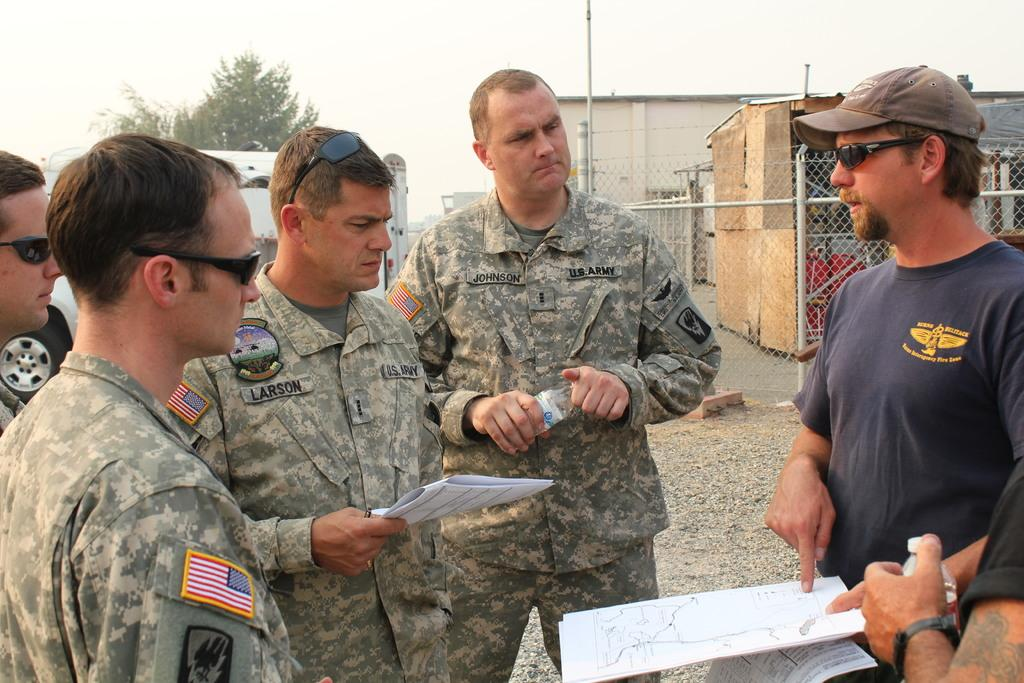What are the men in the image doing? The men in the image are standing on the ground. What are some of the men holding in their hands? Some of the men are holding papers in their hands. What structures can be seen in the background of the image? There is a building, a shed, a mesh, and poles in the background of the image. What type of natural elements are visible in the background of the image? There are trees and the sky visible in the background of the image. What type of mass is the son carrying in the image? There is no son or mass present in the image. 